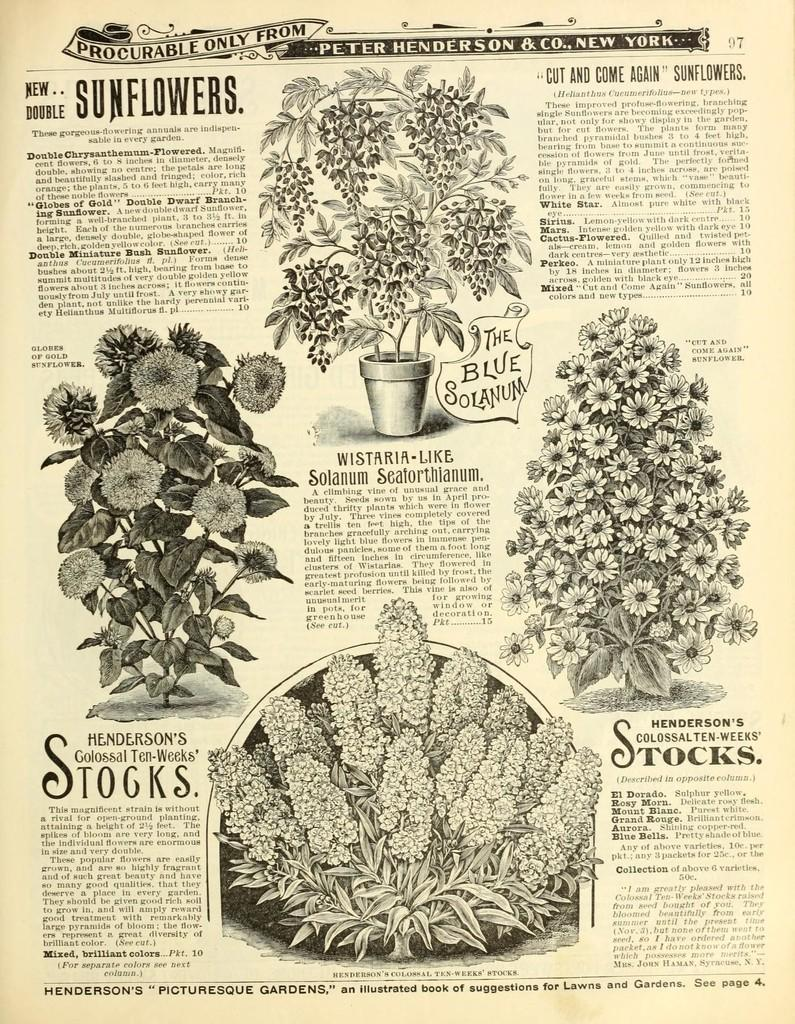What type of living organisms can be seen in the image? There are flowers and plants visible in the image. What is the flowers and plants contained in? There is a flower pot in the image. Is there any text or writing in the image? Yes, there is something written on a paper in the image. What type of floor can be seen in the image? There is no floor visible in the image; it only shows flowers, plants, and a flower pot. What kind of loss is depicted in the image? There is no loss depicted in the image; it features flowers, plants, and a flower pot. 